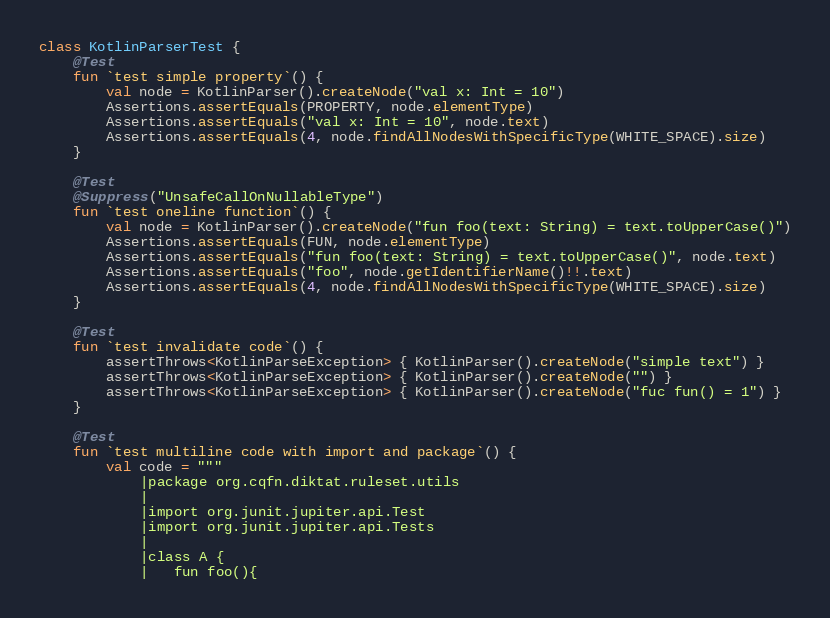<code> <loc_0><loc_0><loc_500><loc_500><_Kotlin_>class KotlinParserTest {
    @Test
    fun `test simple property`() {
        val node = KotlinParser().createNode("val x: Int = 10")
        Assertions.assertEquals(PROPERTY, node.elementType)
        Assertions.assertEquals("val x: Int = 10", node.text)
        Assertions.assertEquals(4, node.findAllNodesWithSpecificType(WHITE_SPACE).size)
    }

    @Test
    @Suppress("UnsafeCallOnNullableType")
    fun `test oneline function`() {
        val node = KotlinParser().createNode("fun foo(text: String) = text.toUpperCase()")
        Assertions.assertEquals(FUN, node.elementType)
        Assertions.assertEquals("fun foo(text: String) = text.toUpperCase()", node.text)
        Assertions.assertEquals("foo", node.getIdentifierName()!!.text)
        Assertions.assertEquals(4, node.findAllNodesWithSpecificType(WHITE_SPACE).size)
    }

    @Test
    fun `test invalidate code`() {
        assertThrows<KotlinParseException> { KotlinParser().createNode("simple text") }
        assertThrows<KotlinParseException> { KotlinParser().createNode("") }
        assertThrows<KotlinParseException> { KotlinParser().createNode("fuc fun() = 1") }
    }

    @Test
    fun `test multiline code with import and package`() {
        val code = """
            |package org.cqfn.diktat.ruleset.utils
            |
            |import org.junit.jupiter.api.Test
            |import org.junit.jupiter.api.Tests
            |
            |class A {
            |   fun foo(){</code> 